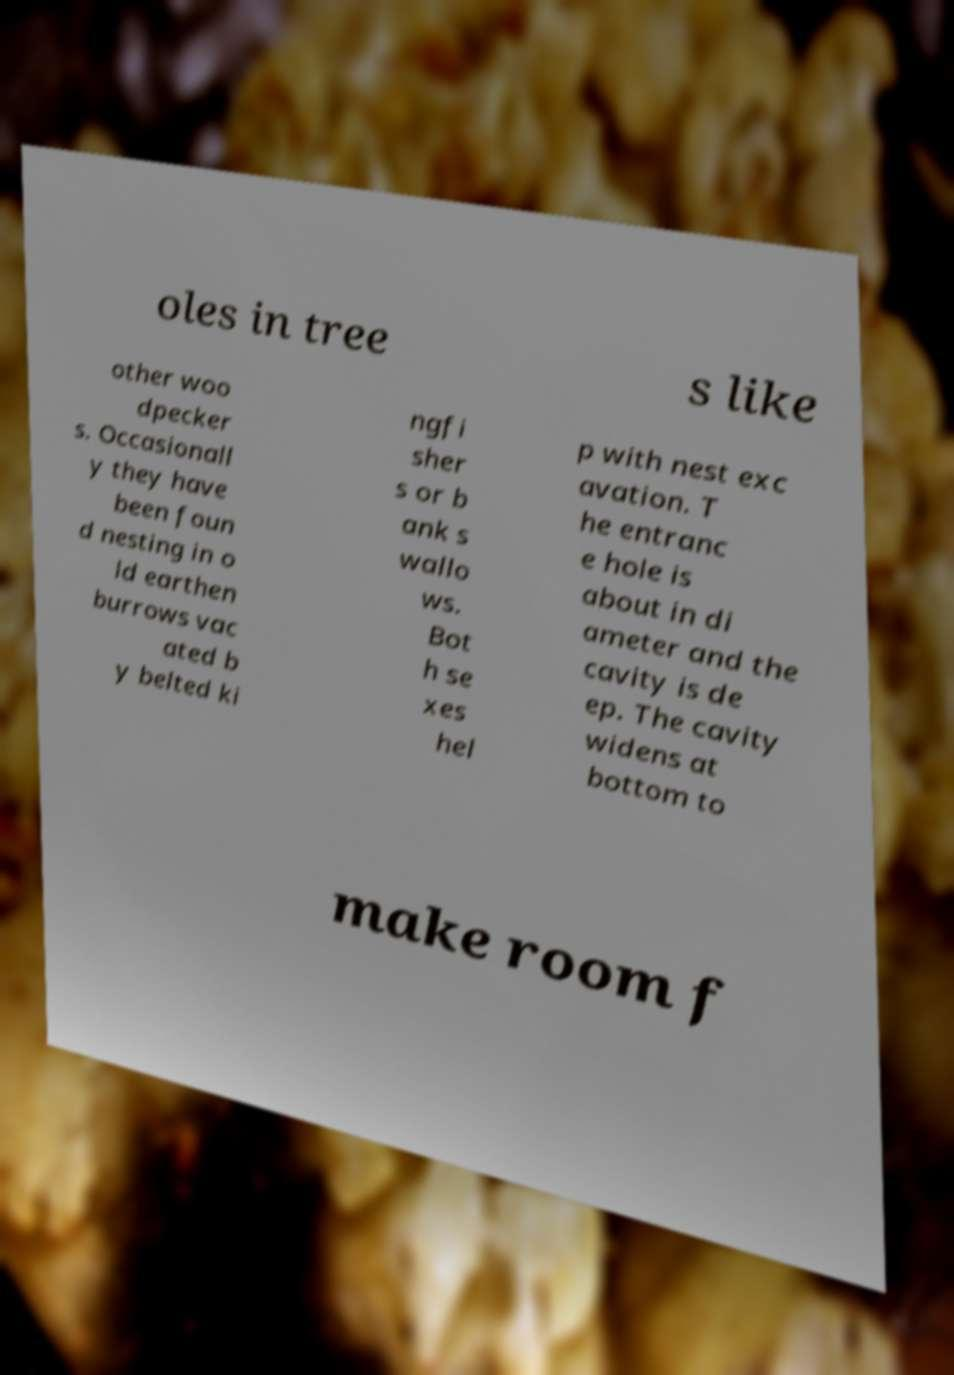For documentation purposes, I need the text within this image transcribed. Could you provide that? oles in tree s like other woo dpecker s. Occasionall y they have been foun d nesting in o ld earthen burrows vac ated b y belted ki ngfi sher s or b ank s wallo ws. Bot h se xes hel p with nest exc avation. T he entranc e hole is about in di ameter and the cavity is de ep. The cavity widens at bottom to make room f 